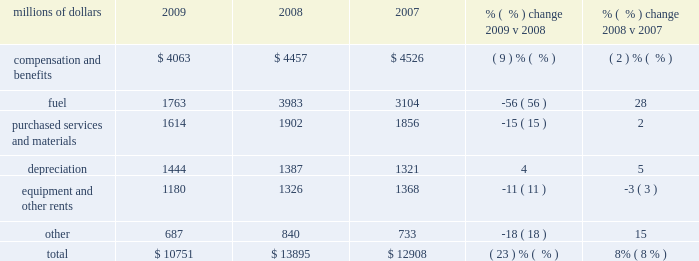Intermodal 2013 decreased volumes and fuel surcharges reduced freight revenue from intermodal shipments in 2009 versus 2008 .
Volume from international traffic decreased 24% ( 24 % ) in 2009 compared to 2008 , reflecting economic conditions , continued weak imports from asia , and diversions to non-uprr served ports .
Additionally , continued weakness in the domestic housing and automotive sectors translated into weak demand in large sectors of the international intermodal market , which also contributed to the volume decline .
Conversely , domestic traffic increased 8% ( 8 % ) in 2009 compared to 2008 .
A new contract with hub group , inc. , which included additional shipments , was executed in the second quarter of 2009 and more than offset the impact of weak market conditions in the second half of 2009 .
Price increases and fuel surcharges generated higher revenue in 2008 , partially offset by lower volume levels .
International traffic declined 11% ( 11 % ) in 2008 , reflecting continued softening of imports from china and the loss of a customer contract .
Notably , the peak intermodal shipping season , which usually starts in the third quarter , was particularly weak in 2008 .
Additionally , continued weakness in domestic housing and automotive sectors translated into weak demand in large sectors of the international intermodal market , which also contributed to lower volumes .
Domestic traffic declined 3% ( 3 % ) in 2008 due to the loss of a customer contract and lower volumes from less-than-truckload shippers .
Additionally , the flood-related embargo on traffic in the midwest during the second quarter hindered intermodal volume levels in 2008 .
Mexico business 2013 each of our commodity groups include revenue from shipments to and from mexico .
Revenue from mexico business decreased 26% ( 26 % ) in 2009 versus 2008 to $ 1.2 billion .
Volume declined in five of our six commodity groups , down 19% ( 19 % ) in 2009 , driven by 32% ( 32 % ) and 24% ( 24 % ) reductions in industrial products and automotive shipments , respectively .
Conversely , energy shipments increased 9% ( 9 % ) in 2009 versus 2008 , partially offsetting these declines .
Revenue from mexico business increased 13% ( 13 % ) to $ 1.6 billion in 2008 compared to 2007 .
Price improvements and fuel surcharges contributed to these increases , partially offset by a 4% ( 4 % ) decline in volume in 2008 compared to 2007 .
Operating expenses millions of dollars 2009 2008 2007 % (  % ) change 2009 v 2008 % (  % ) change 2008 v 2007 .
2009 intermodal revenue international domestic .
What was the change in millions of compensation and benefits from 2007 to 2008? 
Computations: (4457 - 4526)
Answer: -69.0. 